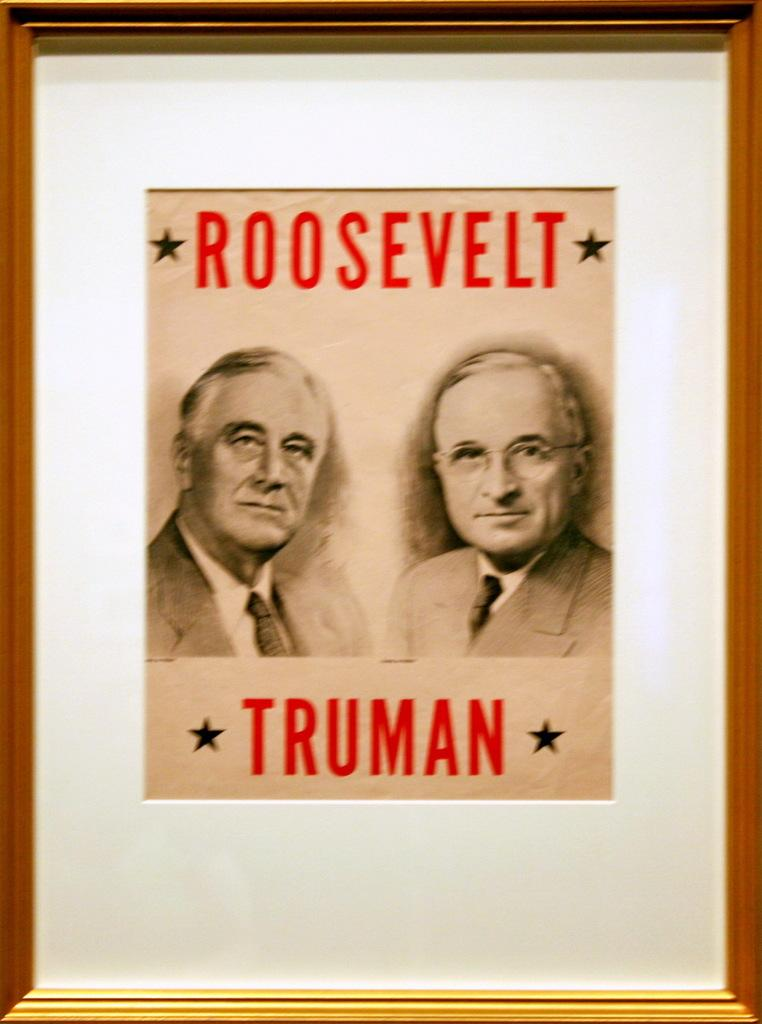What is the main object in the image? There is a frame in the image. What can be seen inside the frame? There are two persons on the frame. What type of bucket is hanging on the wall in the image? There is no bucket present in the image. What account number is associated with the persons on the frame? There is no mention of an account number in the image. 